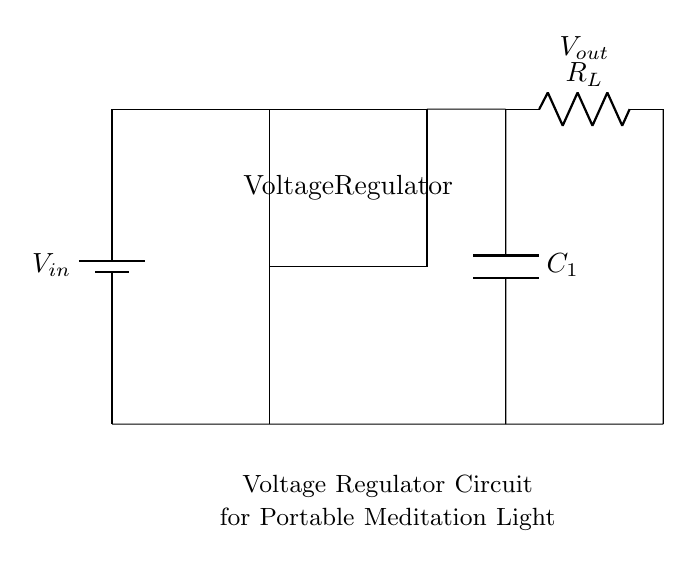What is the primary function of the voltage regulator? The main function of the voltage regulator is to maintain a constant output voltage despite variations in input voltage or load conditions.
Answer: To regulate voltage What type of component is C1? C1 is a capacitor, which is used in the circuit to filter out voltage fluctuations and smooth the output.
Answer: Capacitor How many resistors are present in the circuit? There is one resistor, labeled R_L, which represents the load resistance connected to the output of the voltage regulator.
Answer: One What is the relationship between the input voltage and output voltage? The output voltage is typically lower than the input voltage as the voltage regulator is designed to step down the voltage to the desired level for the load.
Answer: Lower What does the load resistor R_L connect to? The load resistor R_L connects to the output of the voltage regulator and is essential for completing the circuit and allowing current to flow to the load.
Answer: The output of the voltage regulator What is the purpose of the battery in this circuit? The battery serves as the power source, providing the necessary input voltage, V_in, for the entire circuit operation, including the voltage regulator.
Answer: Power source How does the capacitor improve circuit performance? The capacitor improves circuit performance by smoothing out voltage fluctuations at the output, ensuring more stable and constant voltage to the load.
Answer: Smoothing output voltage 